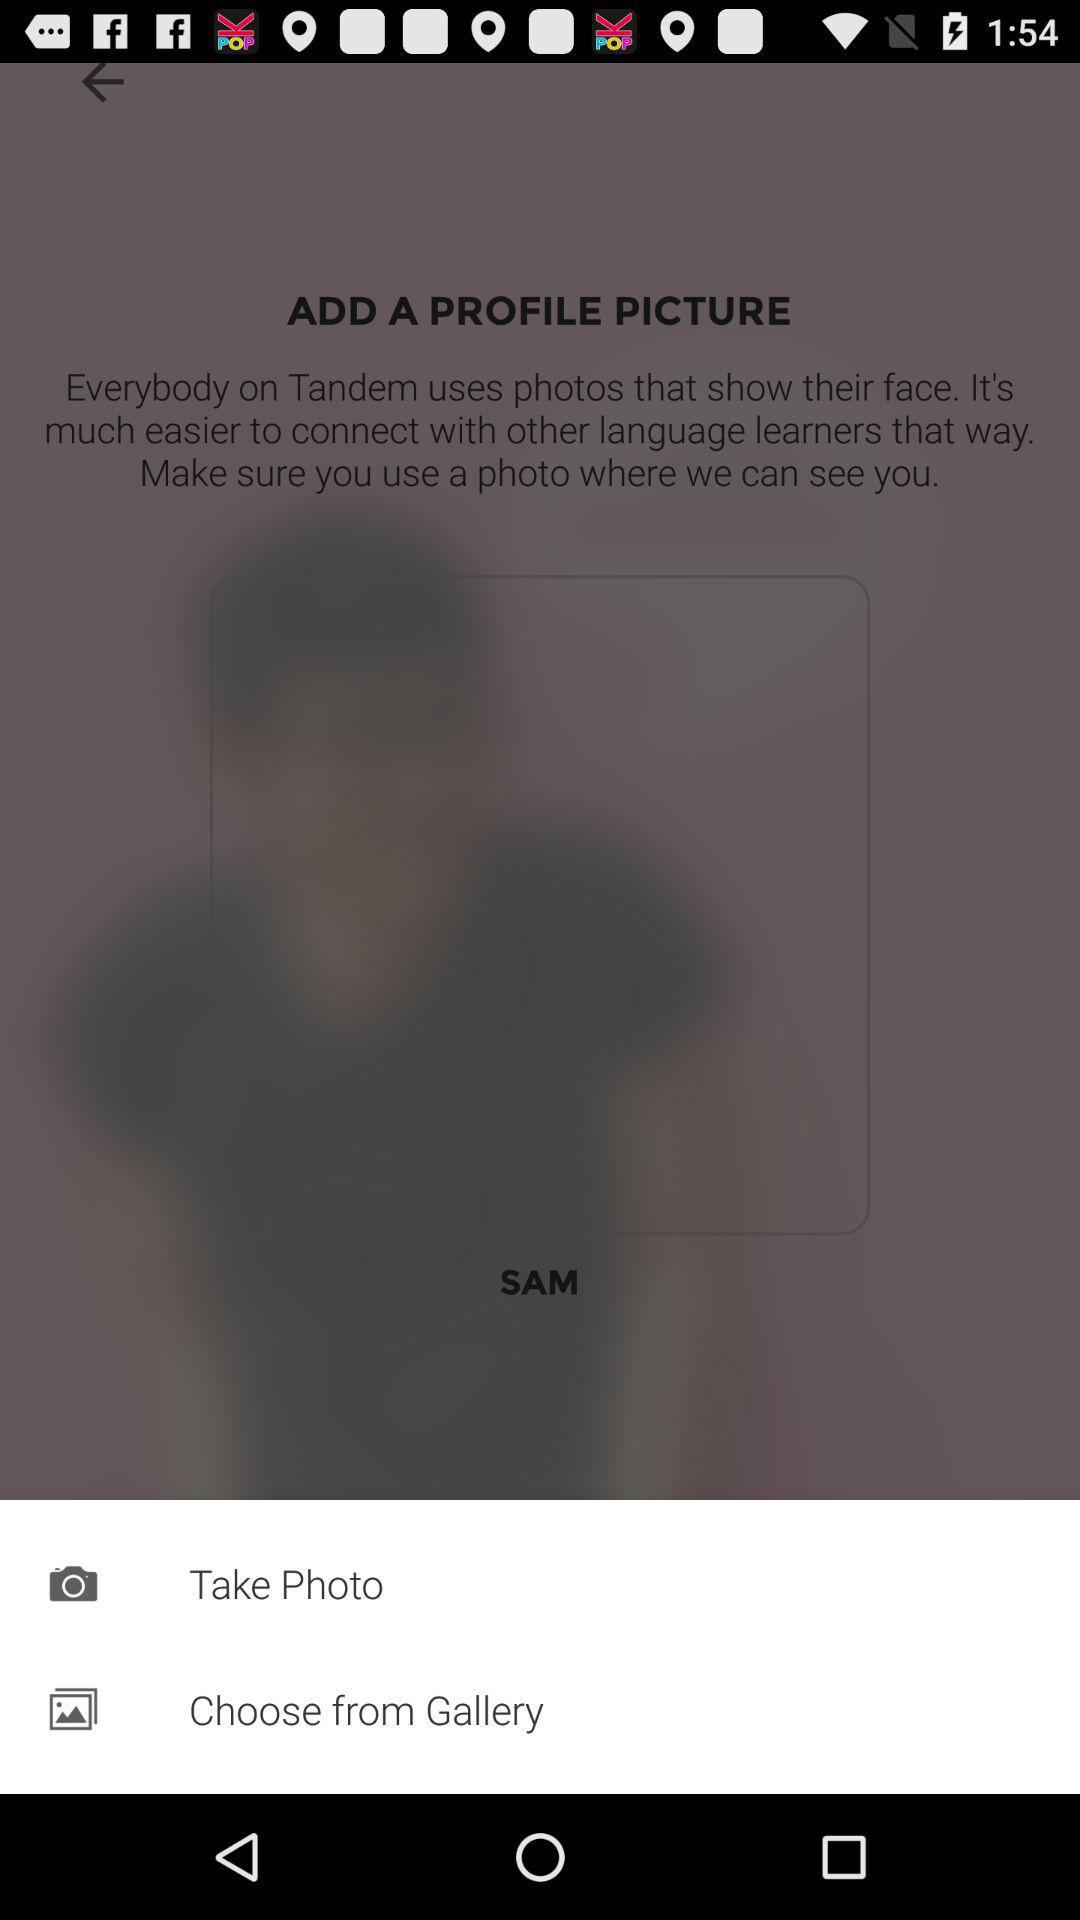How many options do I have to add a profile picture?
Answer the question using a single word or phrase. 2 